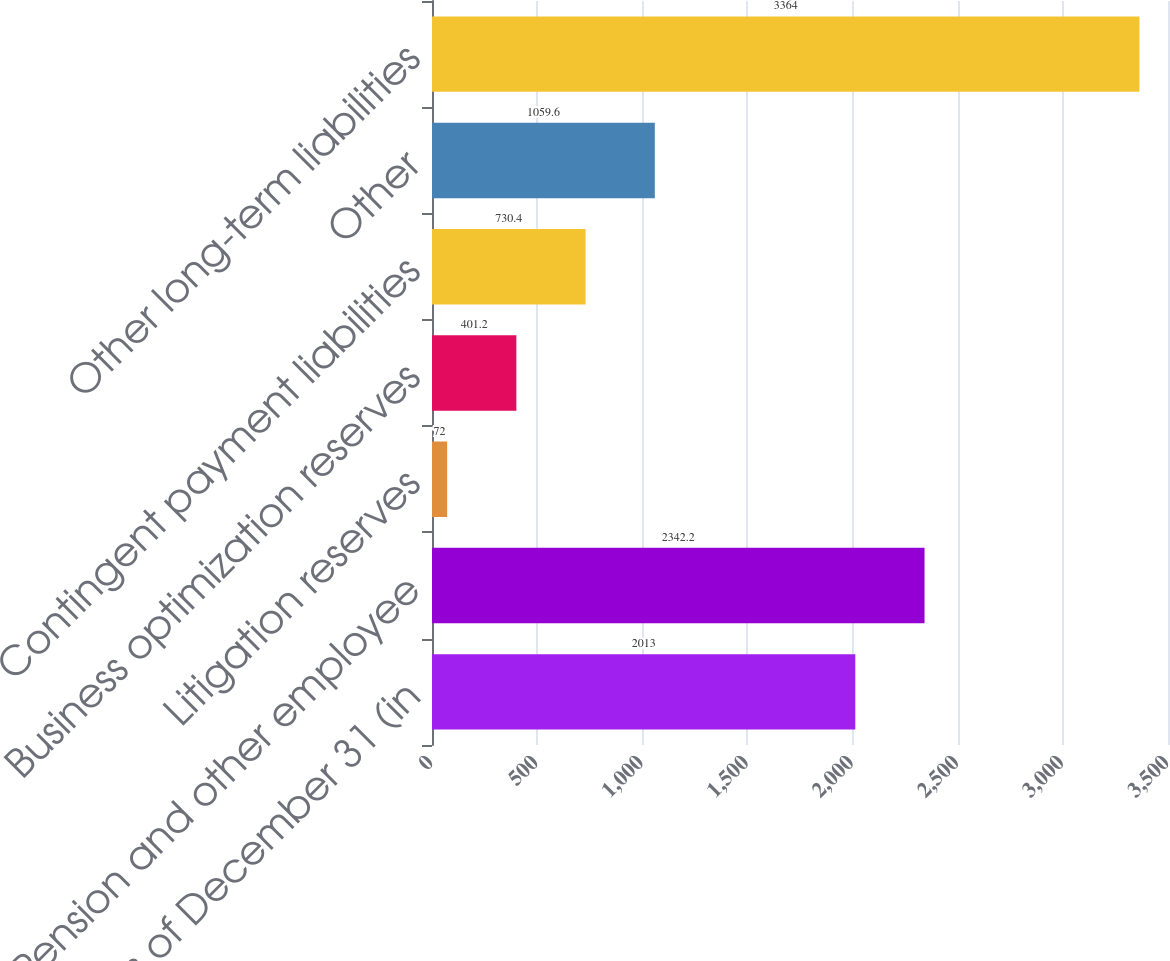Convert chart to OTSL. <chart><loc_0><loc_0><loc_500><loc_500><bar_chart><fcel>as of December 31 (in<fcel>Pension and other employee<fcel>Litigation reserves<fcel>Business optimization reserves<fcel>Contingent payment liabilities<fcel>Other<fcel>Other long-term liabilities<nl><fcel>2013<fcel>2342.2<fcel>72<fcel>401.2<fcel>730.4<fcel>1059.6<fcel>3364<nl></chart> 